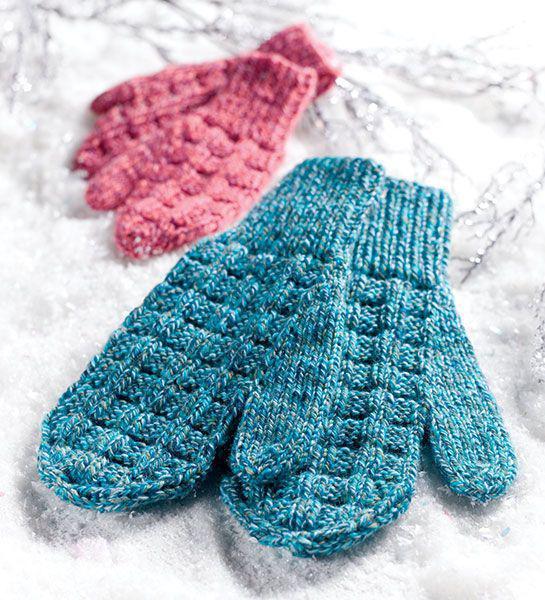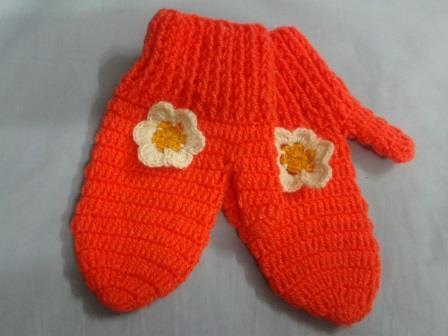The first image is the image on the left, the second image is the image on the right. Evaluate the accuracy of this statement regarding the images: "Each image contains exactly one mitten pair, and all mittens feature reddish-orange color.". Is it true? Answer yes or no. No. The first image is the image on the left, the second image is the image on the right. Examine the images to the left and right. Is the description "There is at least one pair of gloves with the both thumb parts pointing right." accurate? Answer yes or no. Yes. 